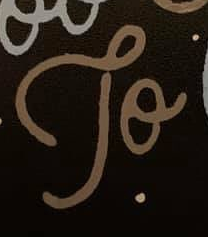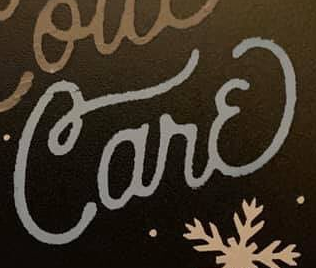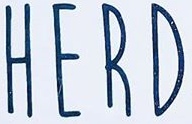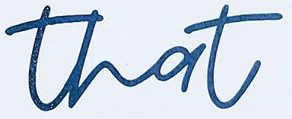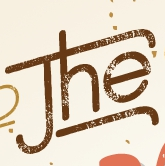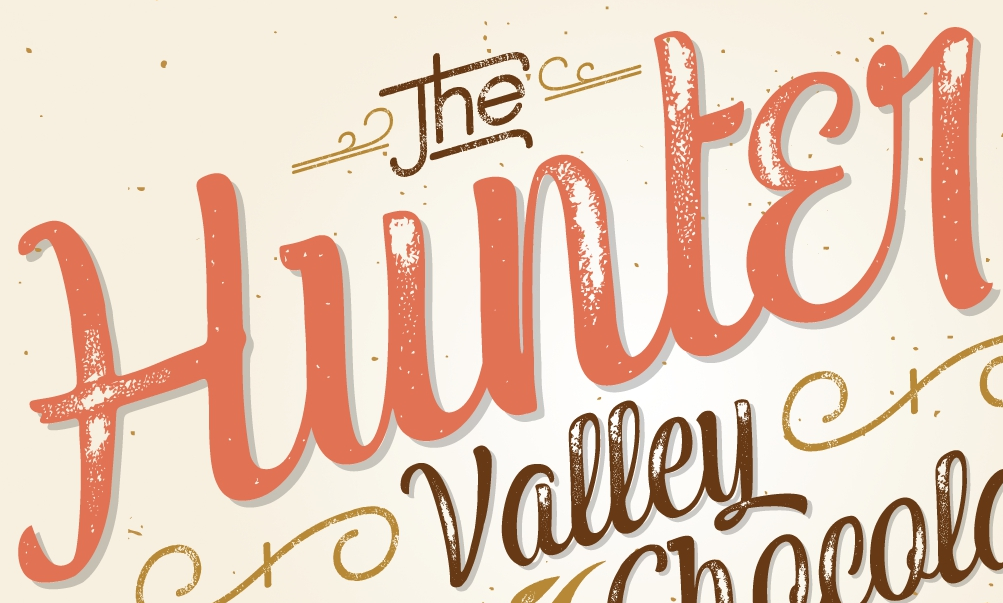What words are shown in these images in order, separated by a semicolon? To; Carɛ; HERD; that; The; Hunter 